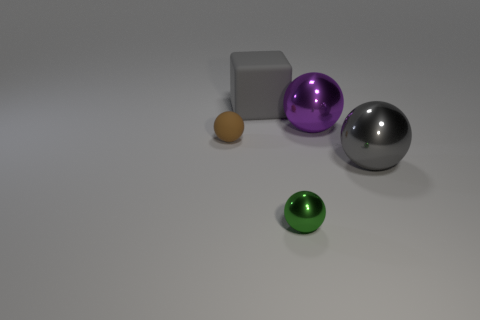Subtract 1 spheres. How many spheres are left? 3 Subtract all purple cubes. Subtract all cyan balls. How many cubes are left? 1 Add 3 tiny brown matte balls. How many objects exist? 8 Subtract all blocks. How many objects are left? 4 Add 2 small balls. How many small balls exist? 4 Subtract 0 red cylinders. How many objects are left? 5 Subtract all small purple rubber blocks. Subtract all purple shiny objects. How many objects are left? 4 Add 5 green metal spheres. How many green metal spheres are left? 6 